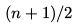Convert formula to latex. <formula><loc_0><loc_0><loc_500><loc_500>( n + 1 ) / 2</formula> 